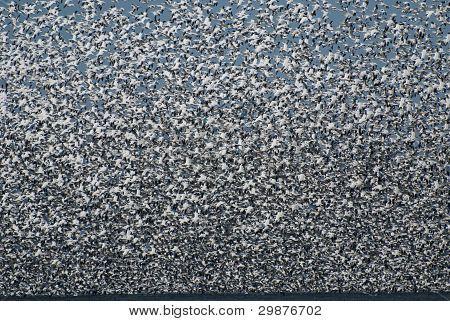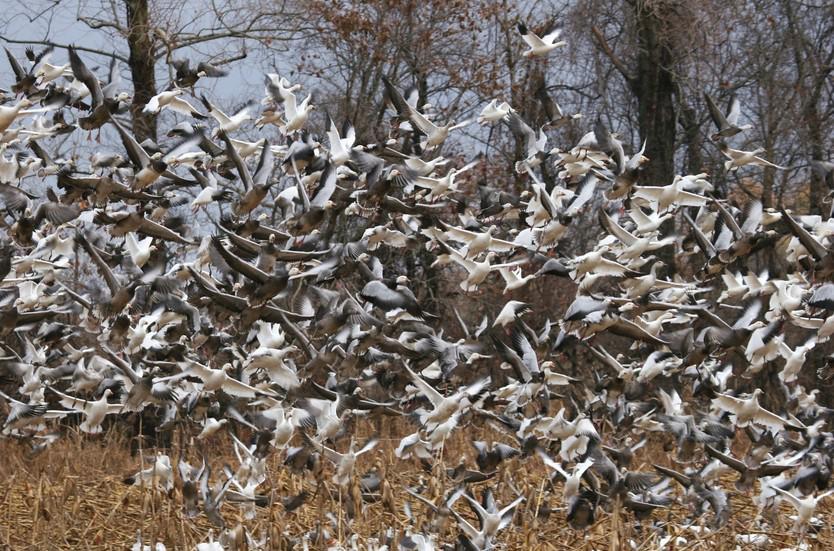The first image is the image on the left, the second image is the image on the right. For the images displayed, is the sentence "A man holding a stick is along the side of a road filled with walking geese, and another man is in the foreground behind the geese." factually correct? Answer yes or no. No. The first image is the image on the left, the second image is the image on the right. Evaluate the accuracy of this statement regarding the images: "An image contains a person facing a large group of ducks,". Is it true? Answer yes or no. No. 